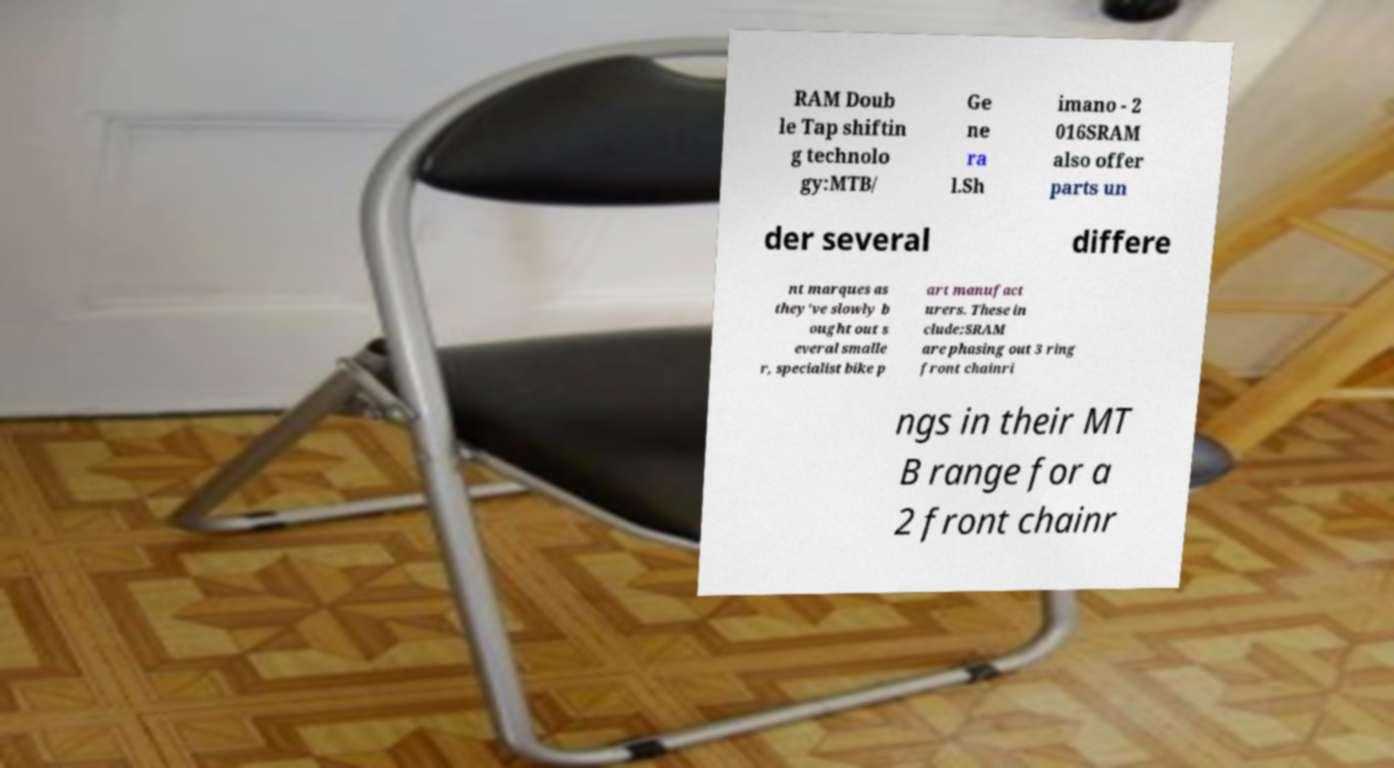Could you extract and type out the text from this image? RAM Doub le Tap shiftin g technolo gy:MTB/ Ge ne ra l.Sh imano - 2 016SRAM also offer parts un der several differe nt marques as they've slowly b ought out s everal smalle r, specialist bike p art manufact urers. These in clude:SRAM are phasing out 3 ring front chainri ngs in their MT B range for a 2 front chainr 